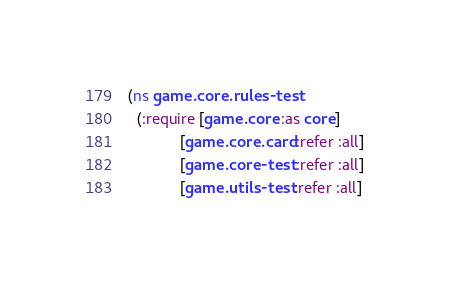<code> <loc_0><loc_0><loc_500><loc_500><_Clojure_>(ns game.core.rules-test
  (:require [game.core :as core]
            [game.core.card :refer :all]
            [game.core-test :refer :all]
            [game.utils-test :refer :all]</code> 